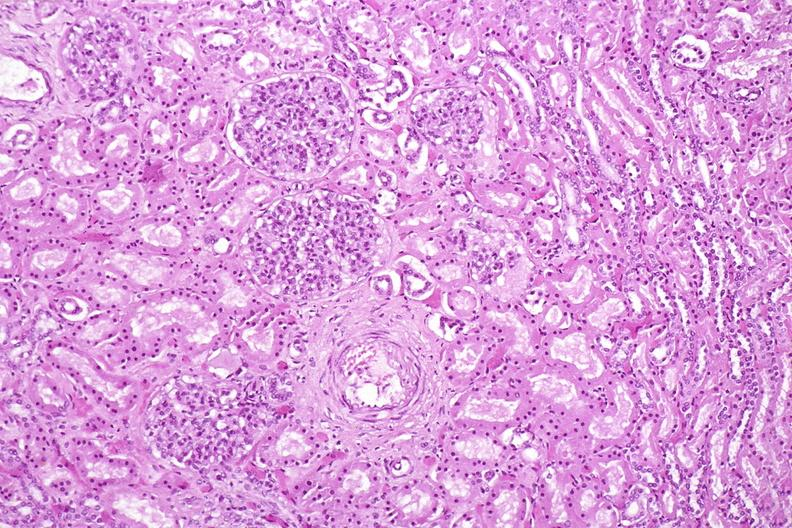what does this image show?
Answer the question using a single word or phrase. Kidney 